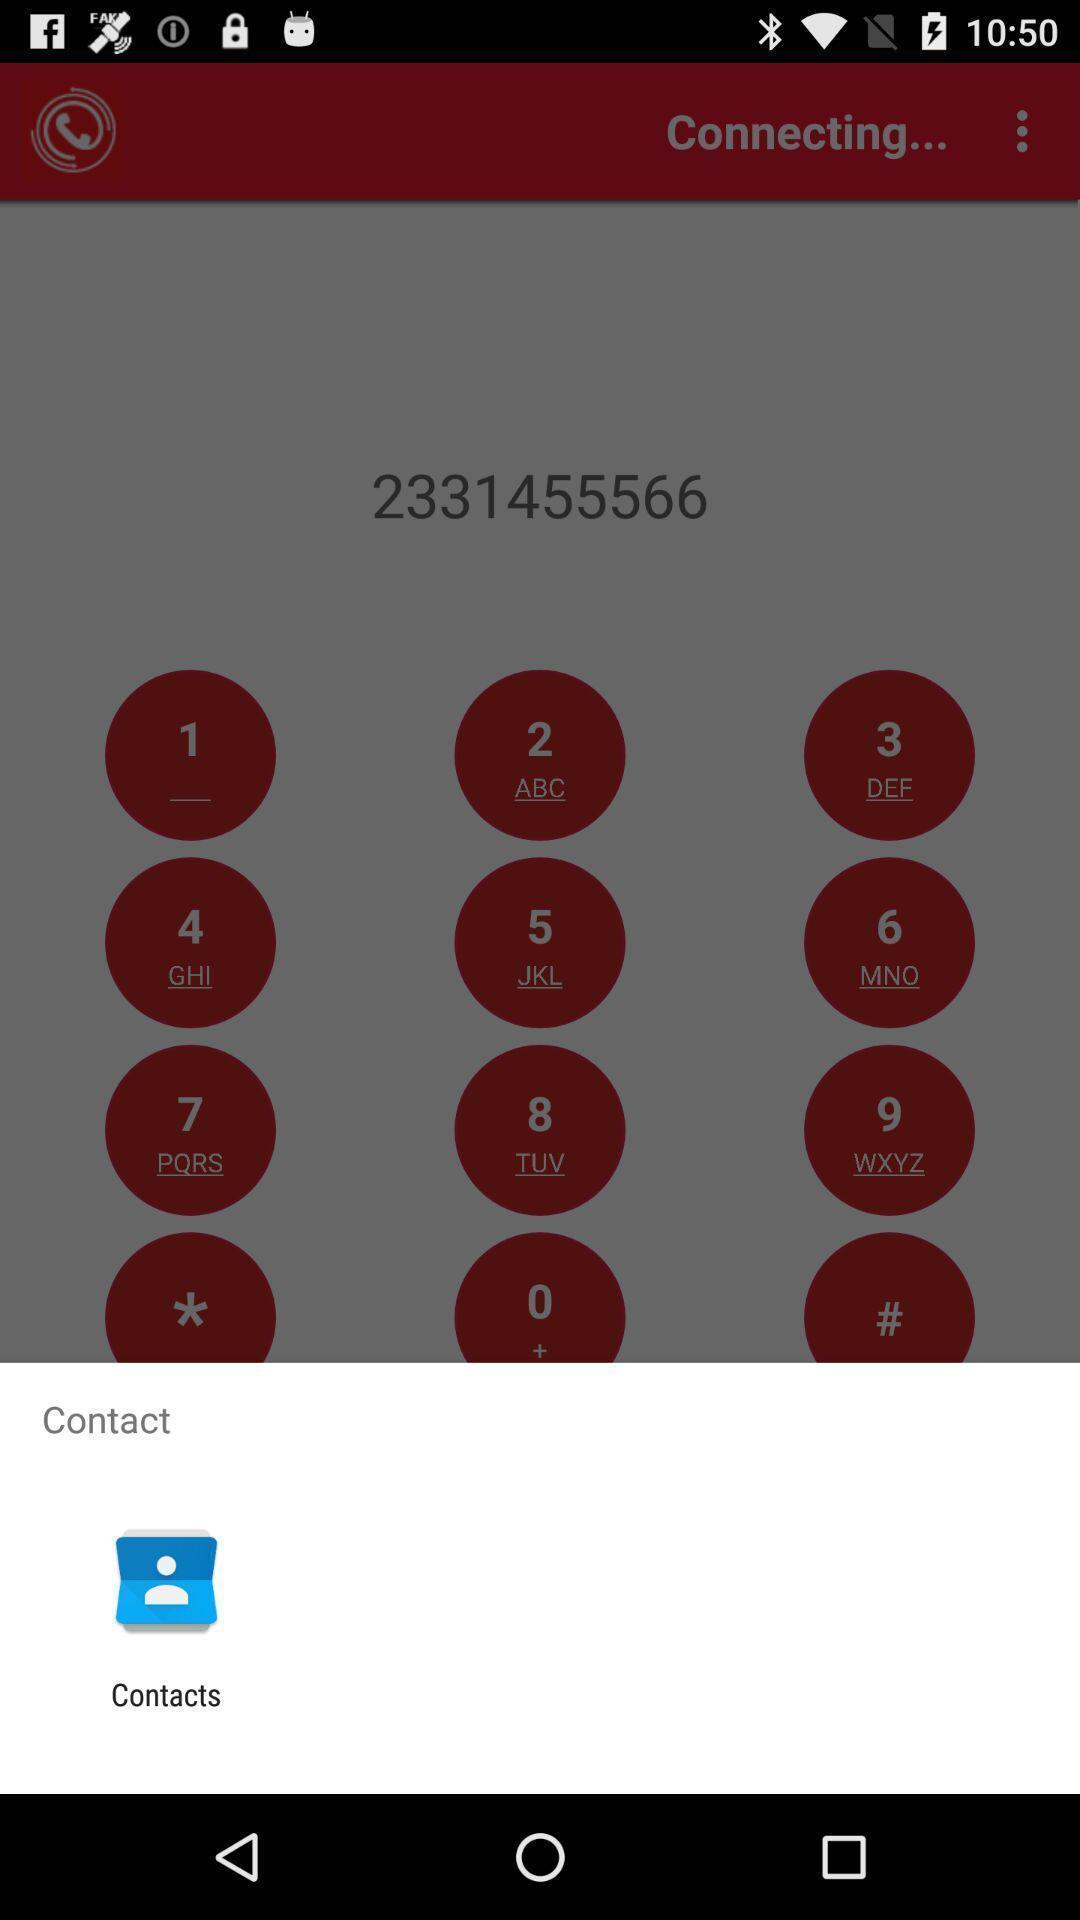Tell me about the visual elements in this screen capture. Popup showing about contact app. 